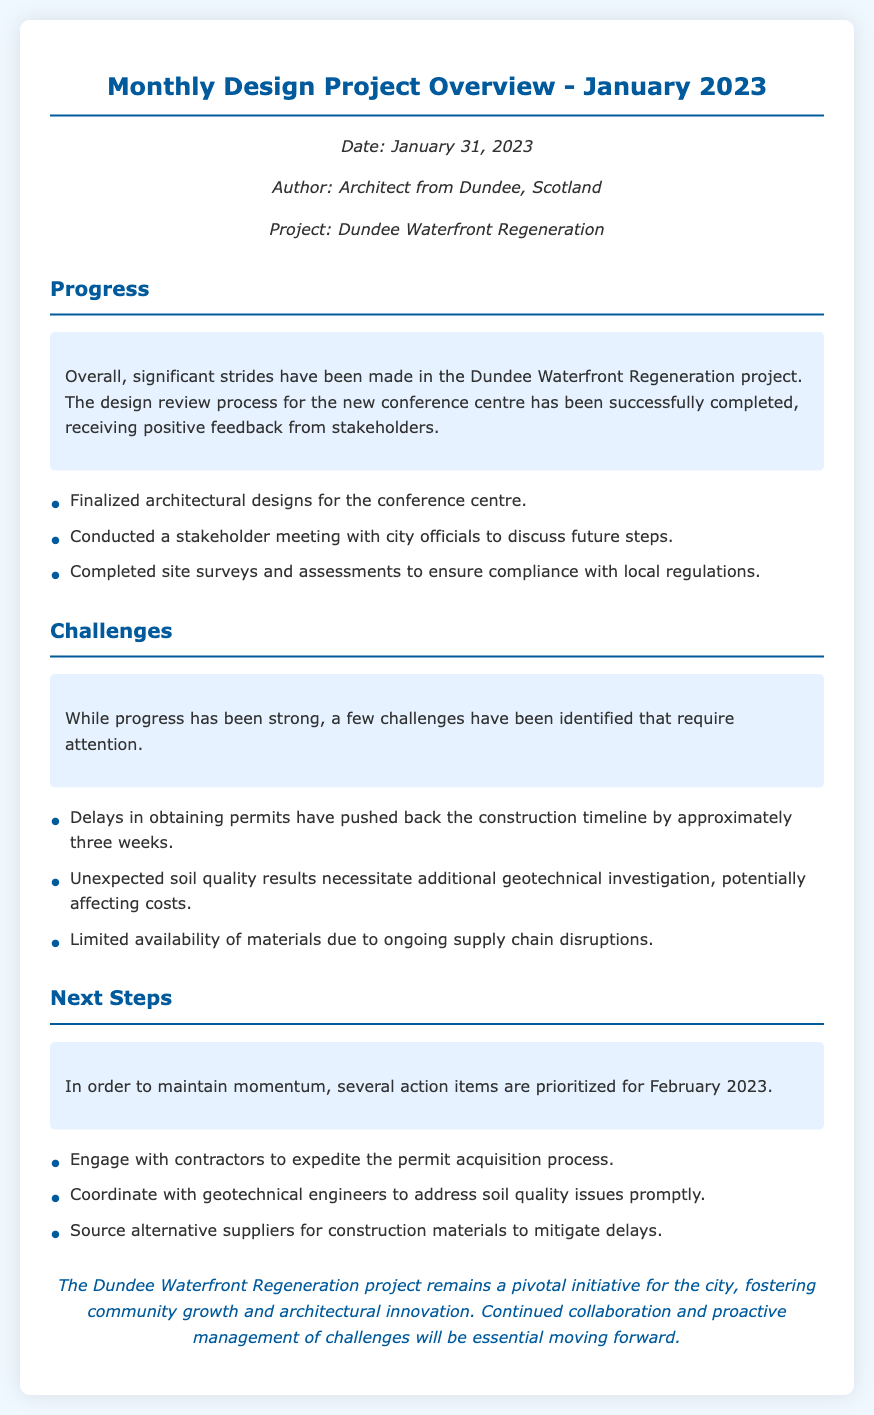What is the date of the memo? The date of the memo is mentioned in the metadata of the document.
Answer: January 31, 2023 Who authored the memo? The author of the memo is indicated in the metadata section.
Answer: Architect from Dundee, Scotland What project is the memo about? The project title is provided in the metadata of the document.
Answer: Dundee Waterfront Regeneration How many challenges are listed in the memo? The number of challenges can be counted from the bullet points under the Challenges section.
Answer: Three What has been completed according to the Progress section? This information can be found in the bullet points detailing progress in the project.
Answer: Site surveys and assessments What is the primary challenge identified in the document? The main challenge is identified in the Challenges section, which summarizes the issues faced.
Answer: Delays in obtaining permits What is one of the next steps mentioned for February 2023? The next steps are outlined in the Next Steps section.
Answer: Engage with contractors What was the outcome of the design review process? The document indicates the result of the design review process in the Progress section.
Answer: Positive feedback from stakeholders 